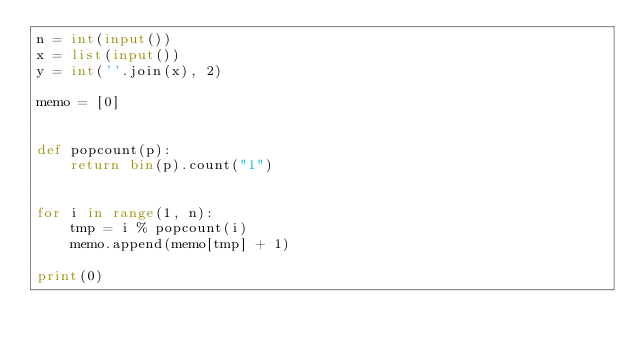<code> <loc_0><loc_0><loc_500><loc_500><_Python_>n = int(input())
x = list(input())
y = int(''.join(x), 2)

memo = [0]


def popcount(p):
    return bin(p).count("1")


for i in range(1, n):
    tmp = i % popcount(i)
    memo.append(memo[tmp] + 1)

print(0)</code> 